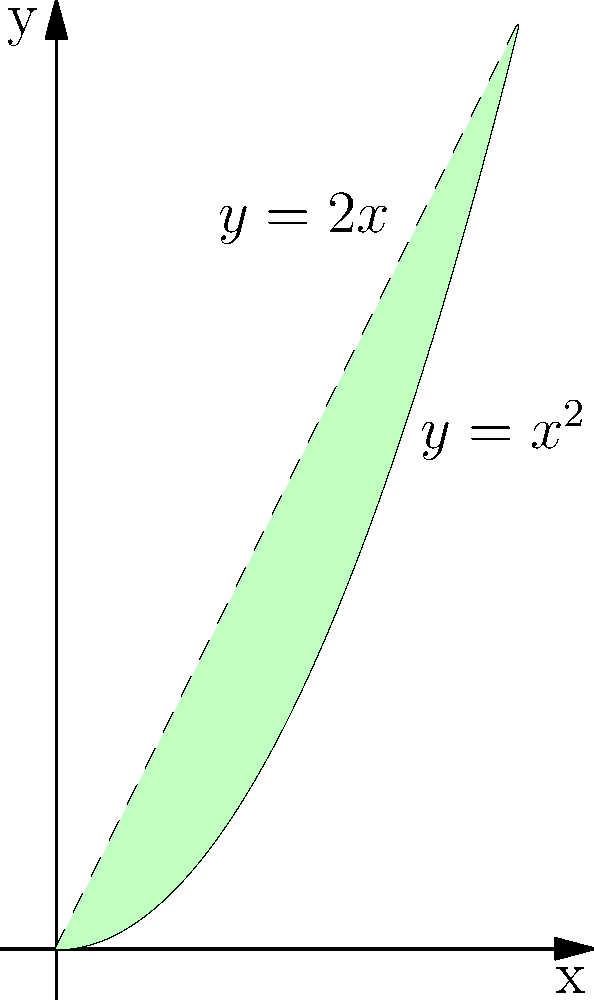As a software engineer working on a machine learning project, you need to calculate the area between two polynomial curves for a feature extraction task. Given the curves $y=x^2$ and $y=2x$, find the area enclosed between these curves in the first quadrant. To find the area between the two curves, we'll follow these steps:

1) First, we need to find the points of intersection of the two curves:
   $x^2 = 2x$
   $x^2 - 2x = 0$
   $x(x - 2) = 0$
   $x = 0$ or $x = 2$

2) The area we're looking for is bounded by $x = 0$ and $x = 2$.

3) To calculate the area, we'll integrate the difference between the upper curve $(2x)$ and the lower curve $(x^2)$ from 0 to 2:

   $A = \int_0^2 (2x - x^2) dx$

4) Let's solve this integral:
   $A = \int_0^2 (2x - x^2) dx$
   $= [x^2 - \frac{1}{3}x^3]_0^2$
   $= (4 - \frac{8}{3}) - (0 - 0)$
   $= 4 - \frac{8}{3}$
   $= \frac{12}{3} - \frac{8}{3}$
   $= \frac{4}{3}$

Therefore, the area between the curves is $\frac{4}{3}$ square units.
Answer: $\frac{4}{3}$ square units 